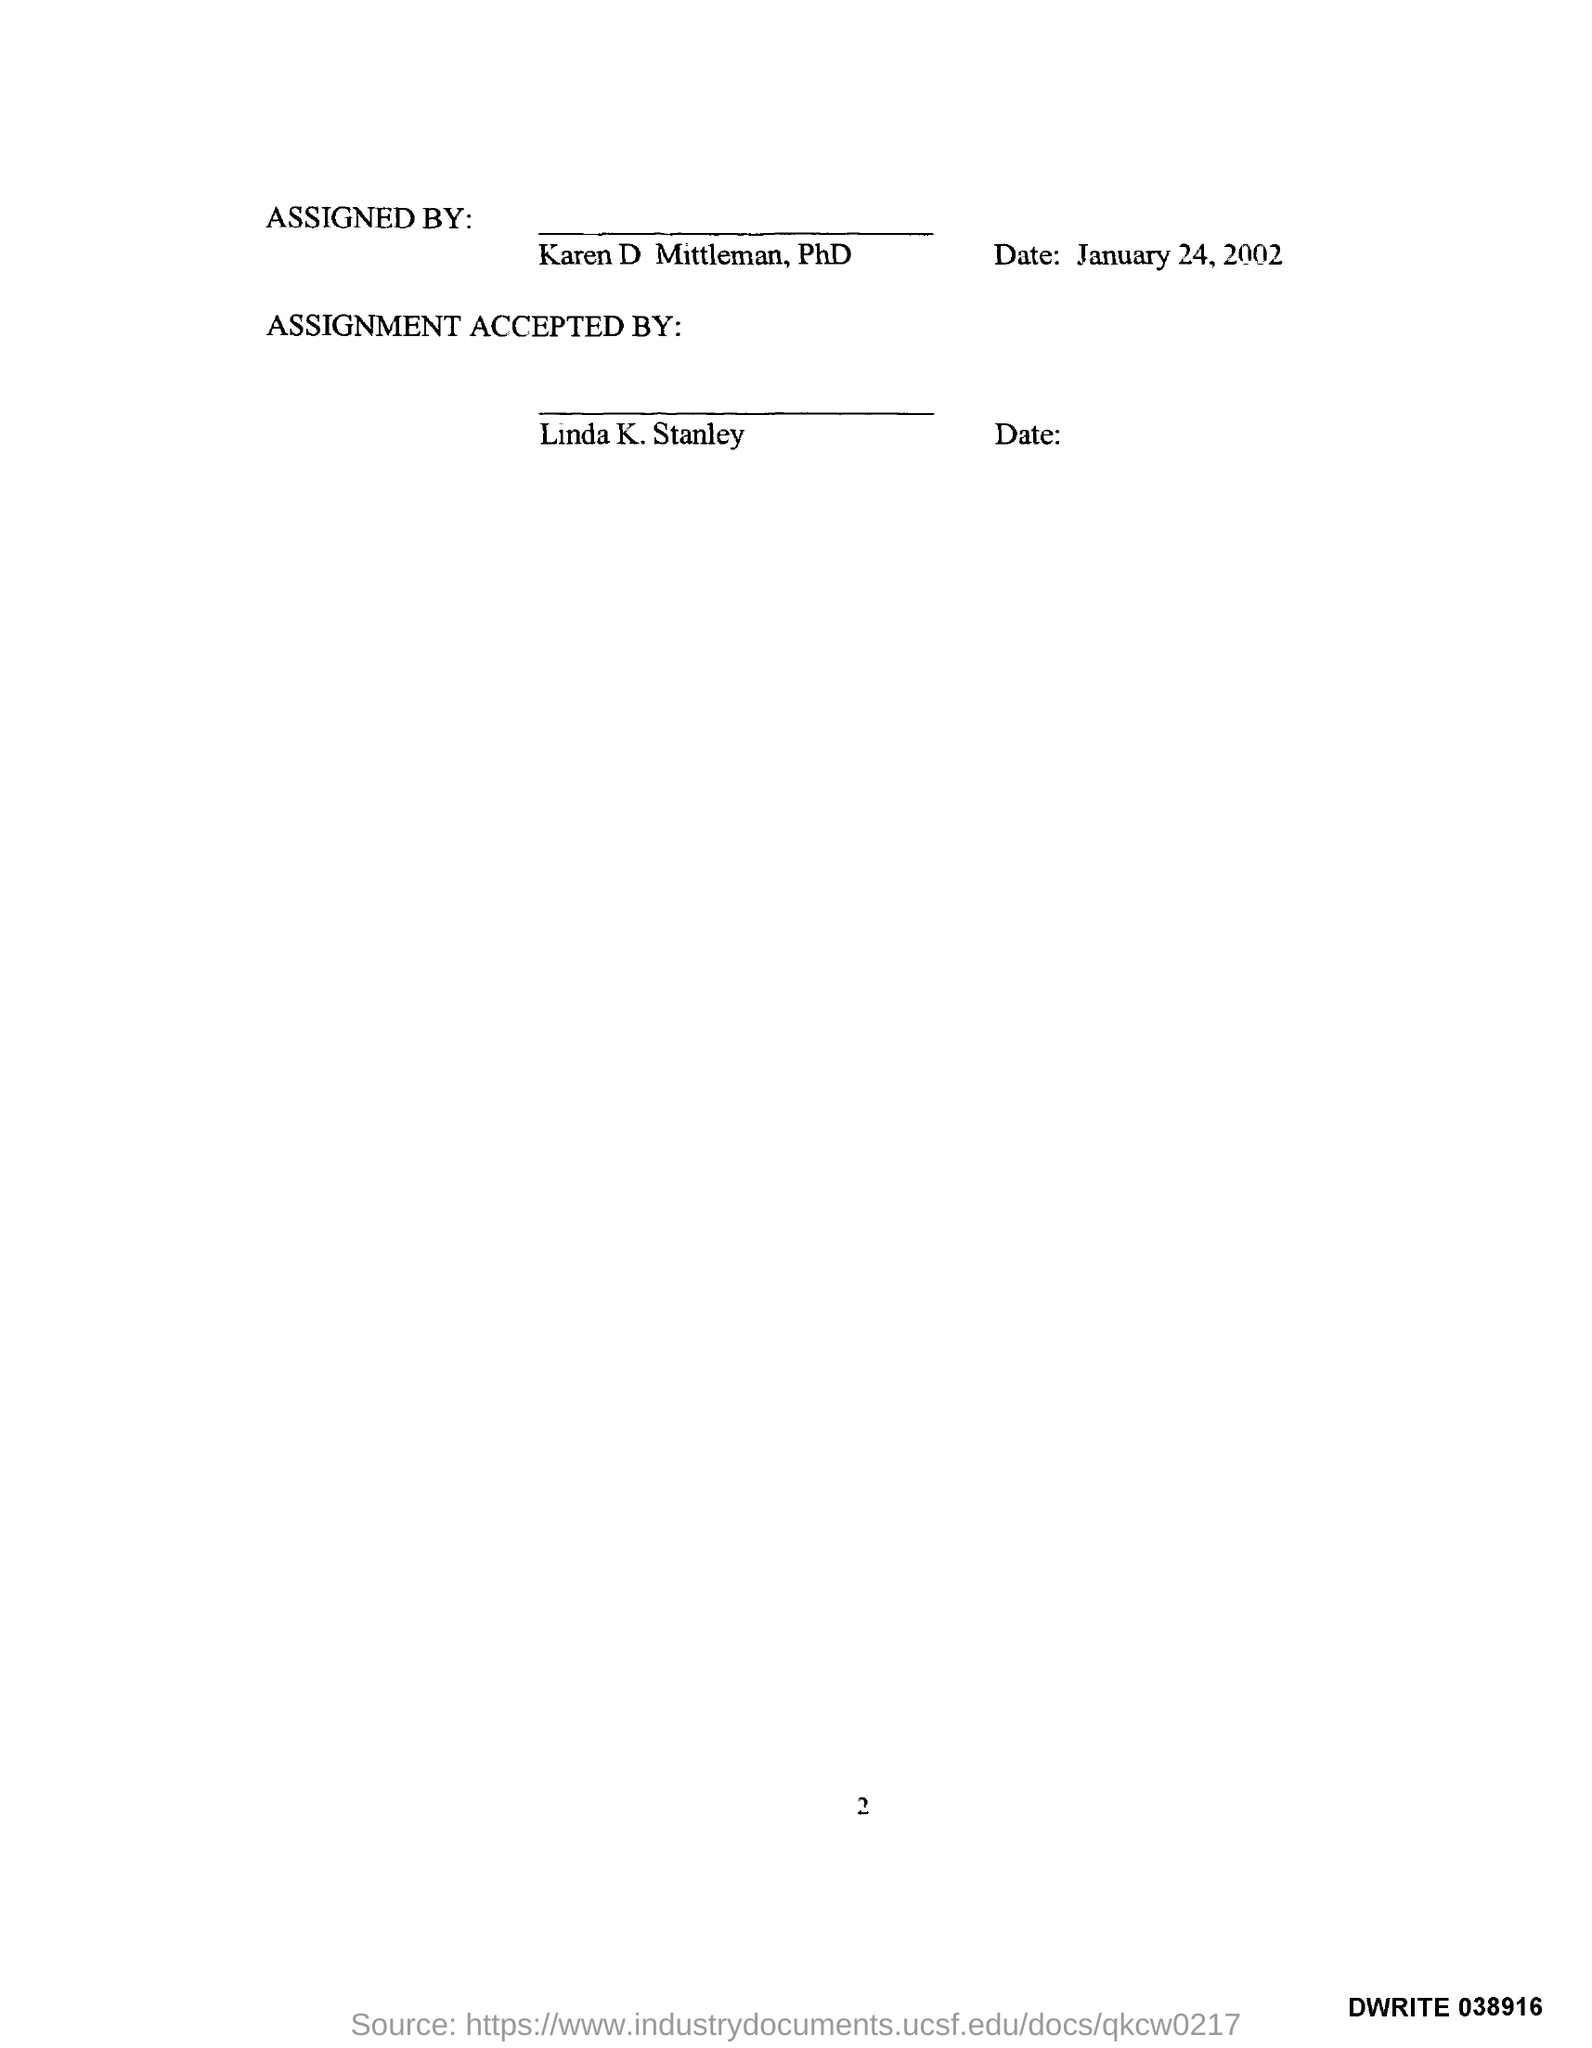What is the page no mentioned in this document? The page number mentioned in the document is 2, as indicated by the numeral at the bottom of the page. 